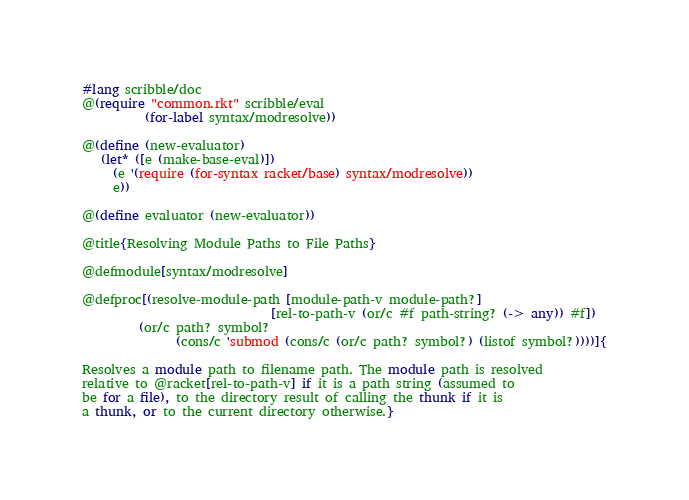<code> <loc_0><loc_0><loc_500><loc_500><_Racket_>#lang scribble/doc
@(require "common.rkt" scribble/eval
          (for-label syntax/modresolve))

@(define (new-evaluator)
   (let* ([e (make-base-eval)])
     (e '(require (for-syntax racket/base) syntax/modresolve))
     e))

@(define evaluator (new-evaluator))

@title{Resolving Module Paths to File Paths}

@defmodule[syntax/modresolve]

@defproc[(resolve-module-path [module-path-v module-path?] 
                              [rel-to-path-v (or/c #f path-string? (-> any)) #f])
         (or/c path? symbol?
               (cons/c 'submod (cons/c (or/c path? symbol?) (listof symbol?))))]{

Resolves a module path to filename path. The module path is resolved
relative to @racket[rel-to-path-v] if it is a path string (assumed to
be for a file), to the directory result of calling the thunk if it is
a thunk, or to the current directory otherwise.}
</code> 